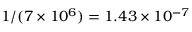<formula> <loc_0><loc_0><loc_500><loc_500>1 / ( 7 \times 1 0 ^ { 6 } ) = 1 . 4 3 \times 1 0 ^ { - 7 }</formula> 